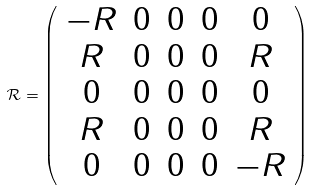<formula> <loc_0><loc_0><loc_500><loc_500>\mathcal { R } = \left ( \begin{array} { c c c c c } - R & 0 & 0 & 0 & 0 \\ R & 0 & 0 & 0 & R \\ 0 & 0 & 0 & 0 & 0 \\ R & 0 & 0 & 0 & R \\ 0 & 0 & 0 & 0 & - R \end{array} \right )</formula> 